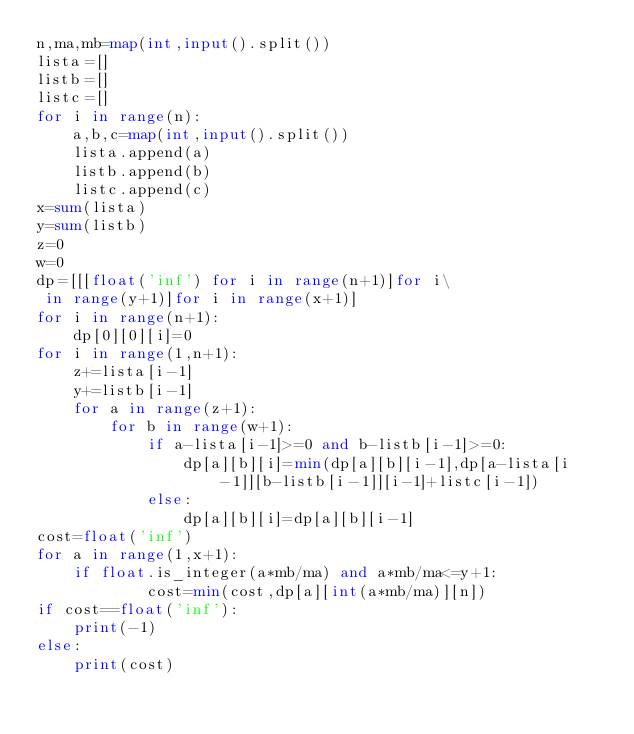<code> <loc_0><loc_0><loc_500><loc_500><_Python_>n,ma,mb=map(int,input().split())
lista=[]
listb=[]
listc=[]
for i in range(n):
    a,b,c=map(int,input().split())
    lista.append(a)
    listb.append(b)
    listc.append(c)
x=sum(lista)
y=sum(listb)
z=0
w=0
dp=[[[float('inf') for i in range(n+1)]for i\
 in range(y+1)]for i in range(x+1)]
for i in range(n+1):
    dp[0][0][i]=0
for i in range(1,n+1):
    z+=lista[i-1]
    y+=listb[i-1]
    for a in range(z+1):
        for b in range(w+1):
            if a-lista[i-1]>=0 and b-listb[i-1]>=0:
                dp[a][b][i]=min(dp[a][b][i-1],dp[a-lista[i-1]][b-listb[i-1]][i-1]+listc[i-1])
            else:
                dp[a][b][i]=dp[a][b][i-1]
cost=float('inf')
for a in range(1,x+1):
    if float.is_integer(a*mb/ma) and a*mb/ma<=y+1:
            cost=min(cost,dp[a][int(a*mb/ma)][n])
if cost==float('inf'):
    print(-1)
else:
    print(cost)
</code> 